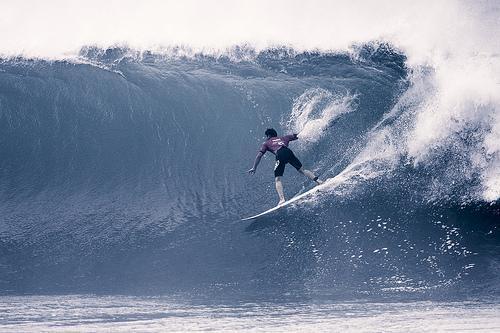How many people are in the picture?
Give a very brief answer. 1. 